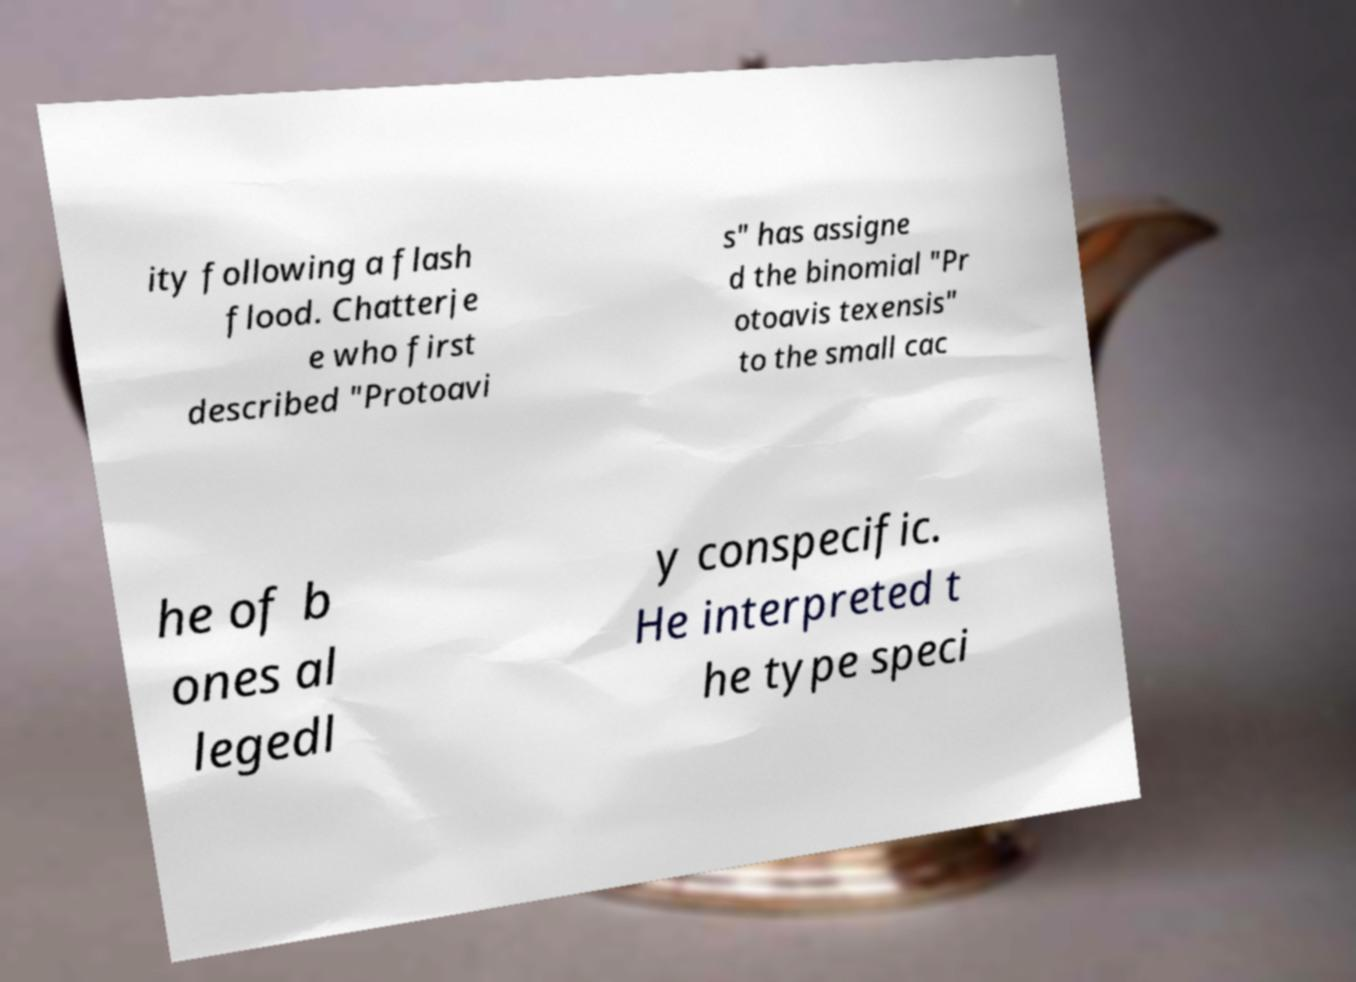For documentation purposes, I need the text within this image transcribed. Could you provide that? ity following a flash flood. Chatterje e who first described "Protoavi s" has assigne d the binomial "Pr otoavis texensis" to the small cac he of b ones al legedl y conspecific. He interpreted t he type speci 